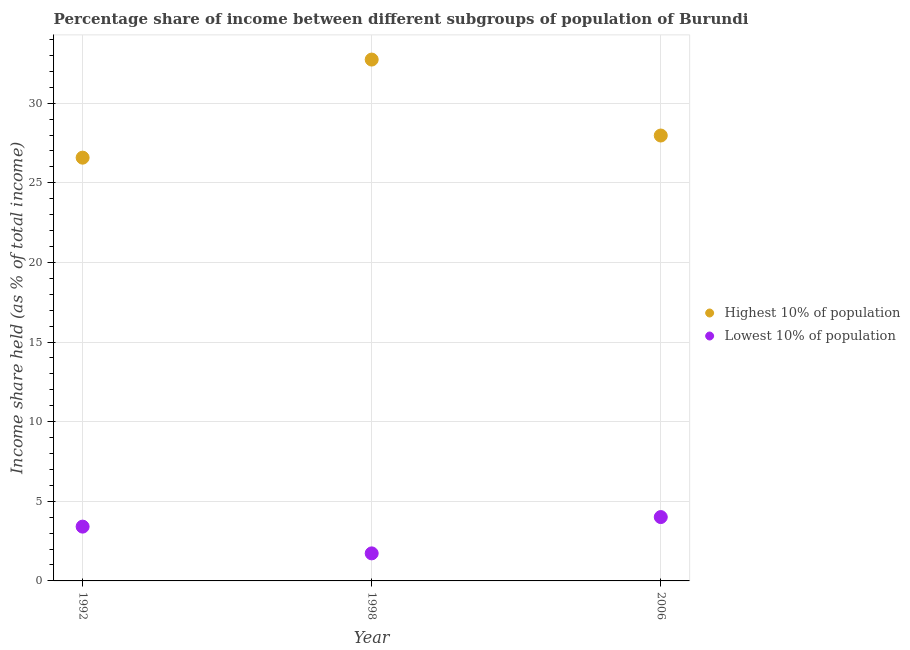How many different coloured dotlines are there?
Your answer should be compact. 2. What is the income share held by lowest 10% of the population in 1998?
Your answer should be compact. 1.73. Across all years, what is the maximum income share held by highest 10% of the population?
Provide a succinct answer. 32.74. Across all years, what is the minimum income share held by lowest 10% of the population?
Provide a succinct answer. 1.73. In which year was the income share held by lowest 10% of the population minimum?
Your answer should be very brief. 1998. What is the total income share held by highest 10% of the population in the graph?
Your answer should be very brief. 87.29. What is the difference between the income share held by lowest 10% of the population in 1992 and that in 1998?
Offer a terse response. 1.68. What is the difference between the income share held by highest 10% of the population in 2006 and the income share held by lowest 10% of the population in 1998?
Your answer should be very brief. 26.24. What is the average income share held by highest 10% of the population per year?
Offer a terse response. 29.1. In the year 1992, what is the difference between the income share held by highest 10% of the population and income share held by lowest 10% of the population?
Ensure brevity in your answer.  23.17. What is the ratio of the income share held by highest 10% of the population in 1992 to that in 1998?
Your response must be concise. 0.81. Is the difference between the income share held by lowest 10% of the population in 1992 and 2006 greater than the difference between the income share held by highest 10% of the population in 1992 and 2006?
Keep it short and to the point. Yes. What is the difference between the highest and the second highest income share held by lowest 10% of the population?
Your response must be concise. 0.6. What is the difference between the highest and the lowest income share held by lowest 10% of the population?
Your answer should be compact. 2.28. In how many years, is the income share held by lowest 10% of the population greater than the average income share held by lowest 10% of the population taken over all years?
Provide a succinct answer. 2. Is the sum of the income share held by highest 10% of the population in 1992 and 2006 greater than the maximum income share held by lowest 10% of the population across all years?
Offer a very short reply. Yes. Is the income share held by highest 10% of the population strictly less than the income share held by lowest 10% of the population over the years?
Offer a very short reply. No. How many dotlines are there?
Make the answer very short. 2. What is the difference between two consecutive major ticks on the Y-axis?
Give a very brief answer. 5. Does the graph contain grids?
Offer a very short reply. Yes. How are the legend labels stacked?
Ensure brevity in your answer.  Vertical. What is the title of the graph?
Offer a terse response. Percentage share of income between different subgroups of population of Burundi. What is the label or title of the X-axis?
Ensure brevity in your answer.  Year. What is the label or title of the Y-axis?
Your response must be concise. Income share held (as % of total income). What is the Income share held (as % of total income) of Highest 10% of population in 1992?
Keep it short and to the point. 26.58. What is the Income share held (as % of total income) of Lowest 10% of population in 1992?
Provide a succinct answer. 3.41. What is the Income share held (as % of total income) in Highest 10% of population in 1998?
Ensure brevity in your answer.  32.74. What is the Income share held (as % of total income) of Lowest 10% of population in 1998?
Offer a terse response. 1.73. What is the Income share held (as % of total income) in Highest 10% of population in 2006?
Your answer should be compact. 27.97. What is the Income share held (as % of total income) in Lowest 10% of population in 2006?
Offer a terse response. 4.01. Across all years, what is the maximum Income share held (as % of total income) of Highest 10% of population?
Your answer should be very brief. 32.74. Across all years, what is the maximum Income share held (as % of total income) of Lowest 10% of population?
Your answer should be very brief. 4.01. Across all years, what is the minimum Income share held (as % of total income) of Highest 10% of population?
Make the answer very short. 26.58. Across all years, what is the minimum Income share held (as % of total income) in Lowest 10% of population?
Your answer should be compact. 1.73. What is the total Income share held (as % of total income) of Highest 10% of population in the graph?
Offer a very short reply. 87.29. What is the total Income share held (as % of total income) in Lowest 10% of population in the graph?
Your response must be concise. 9.15. What is the difference between the Income share held (as % of total income) of Highest 10% of population in 1992 and that in 1998?
Your answer should be very brief. -6.16. What is the difference between the Income share held (as % of total income) of Lowest 10% of population in 1992 and that in 1998?
Keep it short and to the point. 1.68. What is the difference between the Income share held (as % of total income) in Highest 10% of population in 1992 and that in 2006?
Your answer should be very brief. -1.39. What is the difference between the Income share held (as % of total income) in Highest 10% of population in 1998 and that in 2006?
Offer a very short reply. 4.77. What is the difference between the Income share held (as % of total income) of Lowest 10% of population in 1998 and that in 2006?
Provide a short and direct response. -2.28. What is the difference between the Income share held (as % of total income) in Highest 10% of population in 1992 and the Income share held (as % of total income) in Lowest 10% of population in 1998?
Your answer should be compact. 24.85. What is the difference between the Income share held (as % of total income) in Highest 10% of population in 1992 and the Income share held (as % of total income) in Lowest 10% of population in 2006?
Provide a succinct answer. 22.57. What is the difference between the Income share held (as % of total income) in Highest 10% of population in 1998 and the Income share held (as % of total income) in Lowest 10% of population in 2006?
Your response must be concise. 28.73. What is the average Income share held (as % of total income) in Highest 10% of population per year?
Your answer should be very brief. 29.1. What is the average Income share held (as % of total income) of Lowest 10% of population per year?
Your response must be concise. 3.05. In the year 1992, what is the difference between the Income share held (as % of total income) in Highest 10% of population and Income share held (as % of total income) in Lowest 10% of population?
Make the answer very short. 23.17. In the year 1998, what is the difference between the Income share held (as % of total income) of Highest 10% of population and Income share held (as % of total income) of Lowest 10% of population?
Provide a succinct answer. 31.01. In the year 2006, what is the difference between the Income share held (as % of total income) in Highest 10% of population and Income share held (as % of total income) in Lowest 10% of population?
Offer a terse response. 23.96. What is the ratio of the Income share held (as % of total income) of Highest 10% of population in 1992 to that in 1998?
Provide a short and direct response. 0.81. What is the ratio of the Income share held (as % of total income) of Lowest 10% of population in 1992 to that in 1998?
Keep it short and to the point. 1.97. What is the ratio of the Income share held (as % of total income) in Highest 10% of population in 1992 to that in 2006?
Offer a terse response. 0.95. What is the ratio of the Income share held (as % of total income) of Lowest 10% of population in 1992 to that in 2006?
Offer a terse response. 0.85. What is the ratio of the Income share held (as % of total income) of Highest 10% of population in 1998 to that in 2006?
Keep it short and to the point. 1.17. What is the ratio of the Income share held (as % of total income) in Lowest 10% of population in 1998 to that in 2006?
Offer a terse response. 0.43. What is the difference between the highest and the second highest Income share held (as % of total income) of Highest 10% of population?
Provide a short and direct response. 4.77. What is the difference between the highest and the lowest Income share held (as % of total income) of Highest 10% of population?
Make the answer very short. 6.16. What is the difference between the highest and the lowest Income share held (as % of total income) of Lowest 10% of population?
Your answer should be very brief. 2.28. 